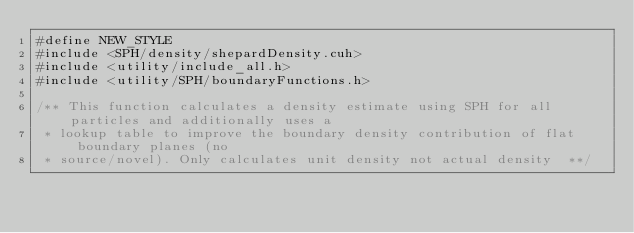Convert code to text. <code><loc_0><loc_0><loc_500><loc_500><_Cuda_>#define NEW_STYLE
#include <SPH/density/shepardDensity.cuh>
#include <utility/include_all.h>
#include <utility/SPH/boundaryFunctions.h>

/** This function calculates a density estimate using SPH for all particles and additionally uses a
 * lookup table to improve the boundary density contribution of flat boundary planes (no
 * source/novel). Only calculates unit density not actual density  **/</code> 